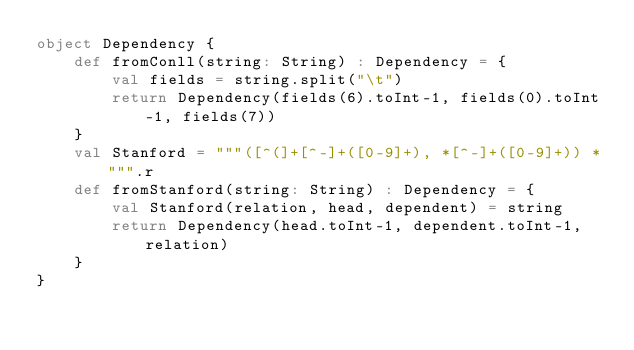<code> <loc_0><loc_0><loc_500><loc_500><_Scala_>object Dependency {
    def fromConll(string: String) : Dependency = {
        val fields = string.split("\t")
        return Dependency(fields(6).toInt-1, fields(0).toInt-1, fields(7))
    }
    val Stanford = """([^(]+[^-]+([0-9]+), *[^-]+([0-9]+)) *""".r
    def fromStanford(string: String) : Dependency = {
        val Stanford(relation, head, dependent) = string
        return Dependency(head.toInt-1, dependent.toInt-1, relation)
    }
}

</code> 